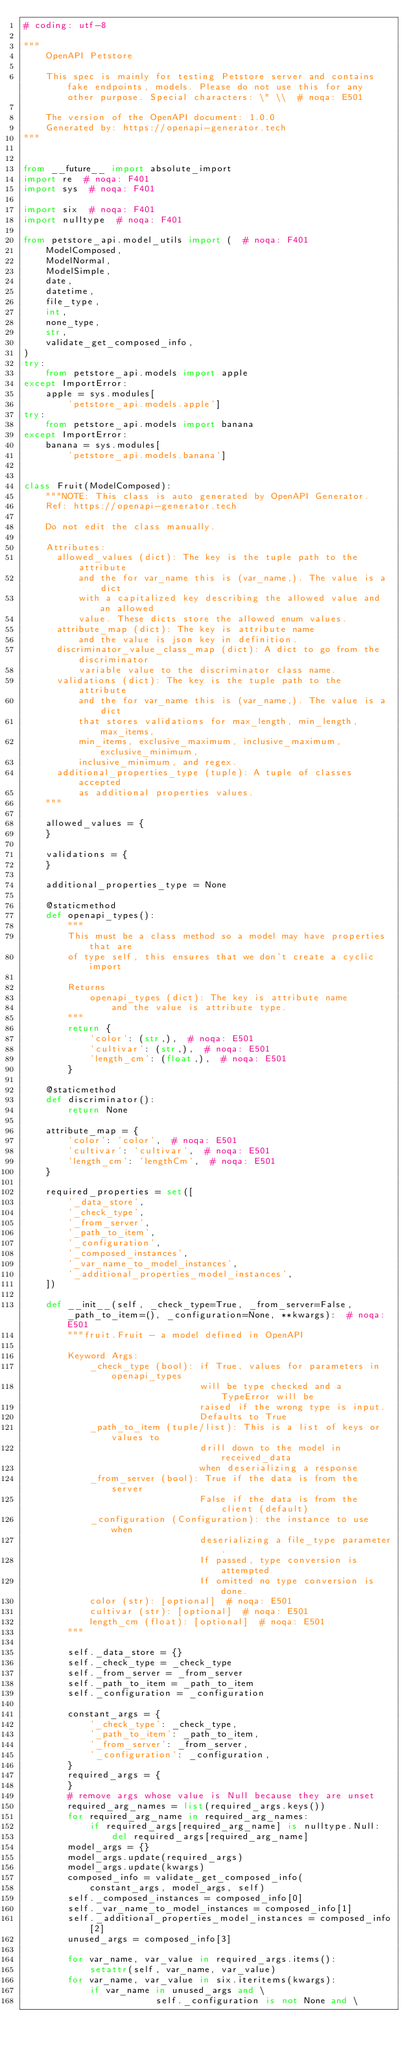<code> <loc_0><loc_0><loc_500><loc_500><_Python_># coding: utf-8

"""
    OpenAPI Petstore

    This spec is mainly for testing Petstore server and contains fake endpoints, models. Please do not use this for any other purpose. Special characters: \" \\  # noqa: E501

    The version of the OpenAPI document: 1.0.0
    Generated by: https://openapi-generator.tech
"""


from __future__ import absolute_import
import re  # noqa: F401
import sys  # noqa: F401

import six  # noqa: F401
import nulltype  # noqa: F401

from petstore_api.model_utils import (  # noqa: F401
    ModelComposed,
    ModelNormal,
    ModelSimple,
    date,
    datetime,
    file_type,
    int,
    none_type,
    str,
    validate_get_composed_info,
)
try:
    from petstore_api.models import apple
except ImportError:
    apple = sys.modules[
        'petstore_api.models.apple']
try:
    from petstore_api.models import banana
except ImportError:
    banana = sys.modules[
        'petstore_api.models.banana']


class Fruit(ModelComposed):
    """NOTE: This class is auto generated by OpenAPI Generator.
    Ref: https://openapi-generator.tech

    Do not edit the class manually.

    Attributes:
      allowed_values (dict): The key is the tuple path to the attribute
          and the for var_name this is (var_name,). The value is a dict
          with a capitalized key describing the allowed value and an allowed
          value. These dicts store the allowed enum values.
      attribute_map (dict): The key is attribute name
          and the value is json key in definition.
      discriminator_value_class_map (dict): A dict to go from the discriminator
          variable value to the discriminator class name.
      validations (dict): The key is the tuple path to the attribute
          and the for var_name this is (var_name,). The value is a dict
          that stores validations for max_length, min_length, max_items,
          min_items, exclusive_maximum, inclusive_maximum, exclusive_minimum,
          inclusive_minimum, and regex.
      additional_properties_type (tuple): A tuple of classes accepted
          as additional properties values.
    """

    allowed_values = {
    }

    validations = {
    }

    additional_properties_type = None

    @staticmethod
    def openapi_types():
        """
        This must be a class method so a model may have properties that are
        of type self, this ensures that we don't create a cyclic import

        Returns
            openapi_types (dict): The key is attribute name
                and the value is attribute type.
        """
        return {
            'color': (str,),  # noqa: E501
            'cultivar': (str,),  # noqa: E501
            'length_cm': (float,),  # noqa: E501
        }

    @staticmethod
    def discriminator():
        return None

    attribute_map = {
        'color': 'color',  # noqa: E501
        'cultivar': 'cultivar',  # noqa: E501
        'length_cm': 'lengthCm',  # noqa: E501
    }

    required_properties = set([
        '_data_store',
        '_check_type',
        '_from_server',
        '_path_to_item',
        '_configuration',
        '_composed_instances',
        '_var_name_to_model_instances',
        '_additional_properties_model_instances',
    ])

    def __init__(self, _check_type=True, _from_server=False, _path_to_item=(), _configuration=None, **kwargs):  # noqa: E501
        """fruit.Fruit - a model defined in OpenAPI

        Keyword Args:
            _check_type (bool): if True, values for parameters in openapi_types
                                will be type checked and a TypeError will be
                                raised if the wrong type is input.
                                Defaults to True
            _path_to_item (tuple/list): This is a list of keys or values to
                                drill down to the model in received_data
                                when deserializing a response
            _from_server (bool): True if the data is from the server
                                False if the data is from the client (default)
            _configuration (Configuration): the instance to use when
                                deserializing a file_type parameter.
                                If passed, type conversion is attempted
                                If omitted no type conversion is done.
            color (str): [optional]  # noqa: E501
            cultivar (str): [optional]  # noqa: E501
            length_cm (float): [optional]  # noqa: E501
        """

        self._data_store = {}
        self._check_type = _check_type
        self._from_server = _from_server
        self._path_to_item = _path_to_item
        self._configuration = _configuration

        constant_args = {
            '_check_type': _check_type,
            '_path_to_item': _path_to_item,
            '_from_server': _from_server,
            '_configuration': _configuration,
        }
        required_args = {
        }
        # remove args whose value is Null because they are unset
        required_arg_names = list(required_args.keys())
        for required_arg_name in required_arg_names:
            if required_args[required_arg_name] is nulltype.Null:
                del required_args[required_arg_name]
        model_args = {}
        model_args.update(required_args)
        model_args.update(kwargs)
        composed_info = validate_get_composed_info(
            constant_args, model_args, self)
        self._composed_instances = composed_info[0]
        self._var_name_to_model_instances = composed_info[1]
        self._additional_properties_model_instances = composed_info[2]
        unused_args = composed_info[3]

        for var_name, var_value in required_args.items():
            setattr(self, var_name, var_value)
        for var_name, var_value in six.iteritems(kwargs):
            if var_name in unused_args and \
                        self._configuration is not None and \</code> 